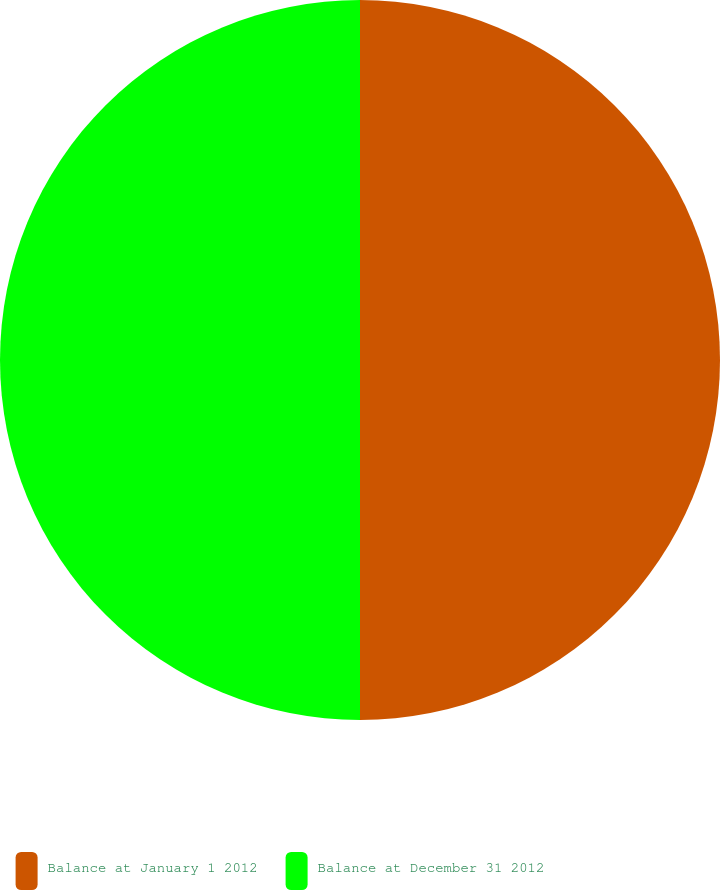<chart> <loc_0><loc_0><loc_500><loc_500><pie_chart><fcel>Balance at January 1 2012<fcel>Balance at December 31 2012<nl><fcel>50.0%<fcel>50.0%<nl></chart> 